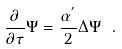<formula> <loc_0><loc_0><loc_500><loc_500>\frac { \partial } { \partial \tau } \Psi = \frac { \alpha ^ { ^ { \prime } } } { 2 } \Delta \Psi \ .</formula> 